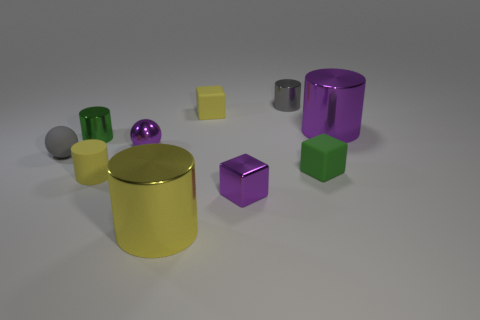Subtract all purple cylinders. How many cylinders are left? 4 Subtract all gray balls. How many green cylinders are left? 1 Subtract all matte cylinders. How many cylinders are left? 4 Subtract 3 cylinders. How many cylinders are left? 2 Subtract all brown cylinders. Subtract all brown cubes. How many cylinders are left? 5 Subtract all cyan matte things. Subtract all purple cylinders. How many objects are left? 9 Add 6 green cylinders. How many green cylinders are left? 7 Add 2 big brown metallic cylinders. How many big brown metallic cylinders exist? 2 Subtract 0 blue spheres. How many objects are left? 10 Subtract all cubes. How many objects are left? 7 